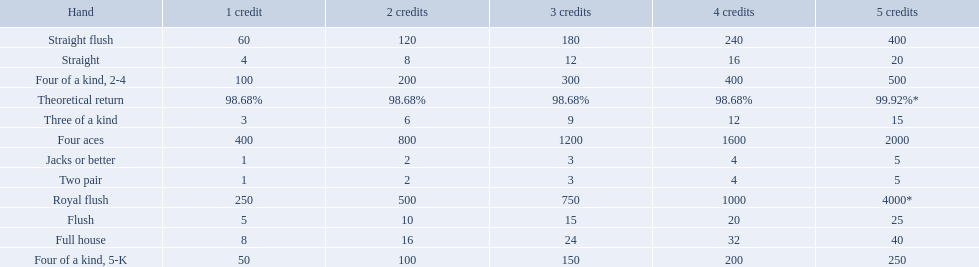What is the values in the 5 credits area? 4000*, 400, 2000, 500, 250, 40, 25, 20, 15, 5, 5. Which of these is for a four of a kind? 500, 250. What is the higher value? 500. What hand is this for Four of a kind, 2-4. 